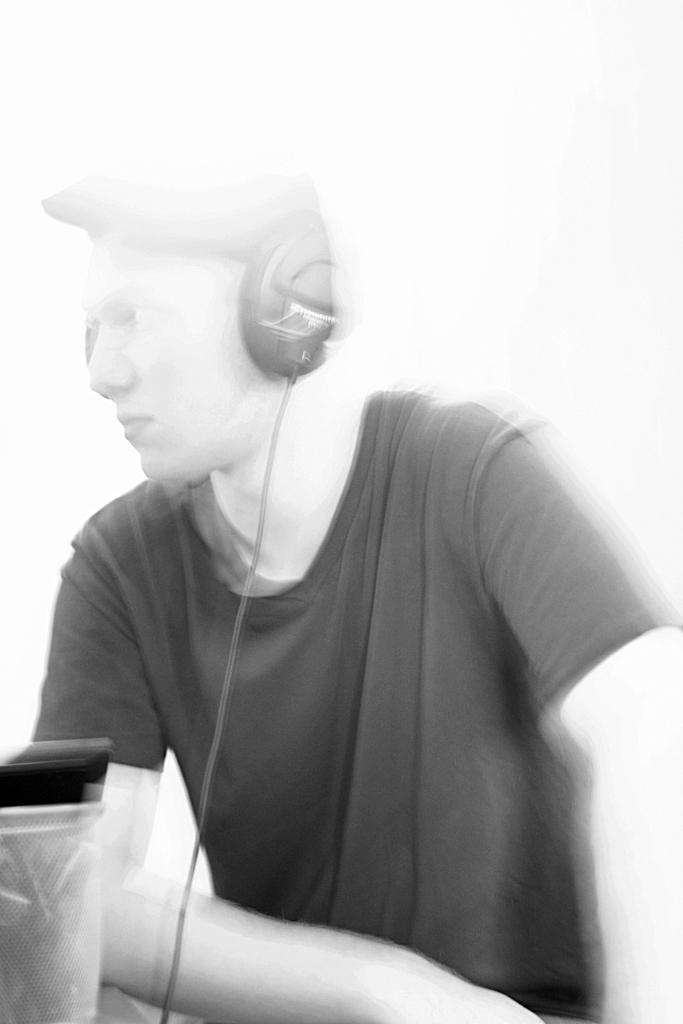Describe this image in one or two sentences. This is an edited picture, in this picture there is a person wearing headphones. On the left there is a box, in the box there are pens. 